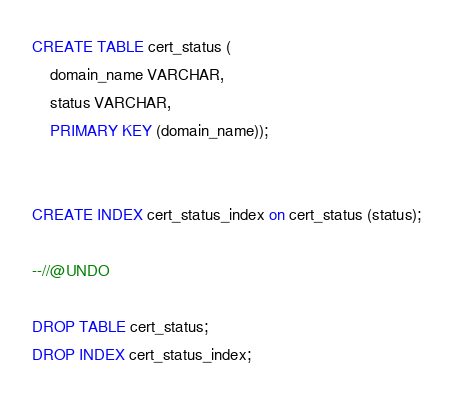Convert code to text. <code><loc_0><loc_0><loc_500><loc_500><_SQL_>CREATE TABLE cert_status (
    domain_name VARCHAR,
    status VARCHAR,
    PRIMARY KEY (domain_name));


CREATE INDEX cert_status_index on cert_status (status);

--//@UNDO

DROP TABLE cert_status;
DROP INDEX cert_status_index;</code> 